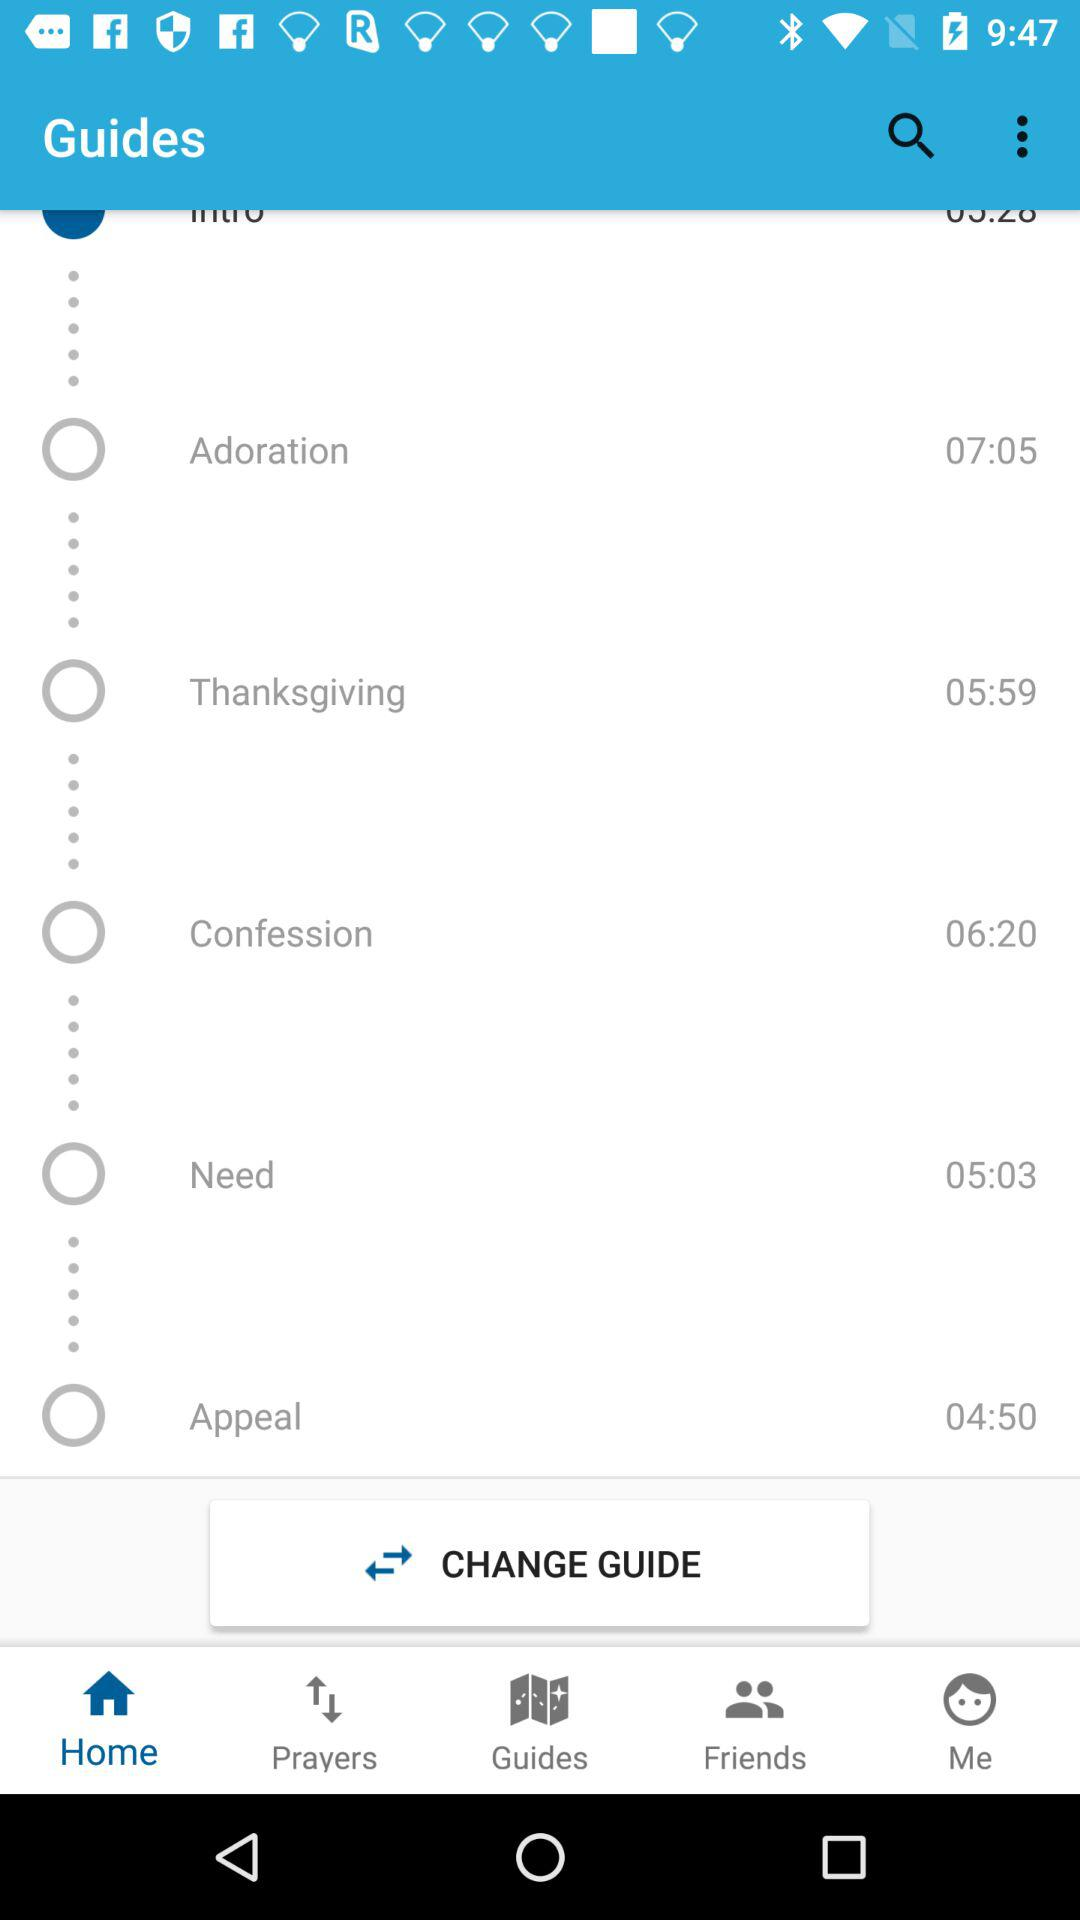How many guides are there in total?
Answer the question using a single word or phrase. 6 